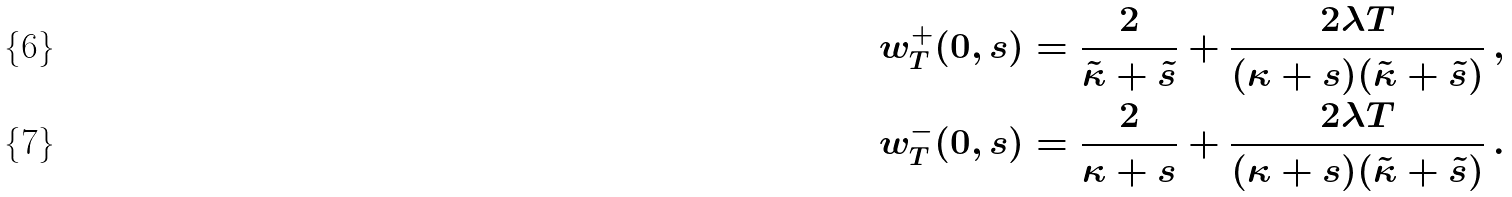Convert formula to latex. <formula><loc_0><loc_0><loc_500><loc_500>w _ { T } ^ { + } ( 0 , s ) & = \frac { 2 } { \tilde { \kappa } + \tilde { s } } + \frac { 2 \lambda T } { ( \kappa + s ) ( \tilde { \kappa } + \tilde { s } ) } \, , \\ w _ { T } ^ { - } ( 0 , s ) & = \frac { 2 } { \kappa + s } + \frac { 2 \lambda T } { ( \kappa + s ) ( \tilde { \kappa } + \tilde { s } ) } \, .</formula> 